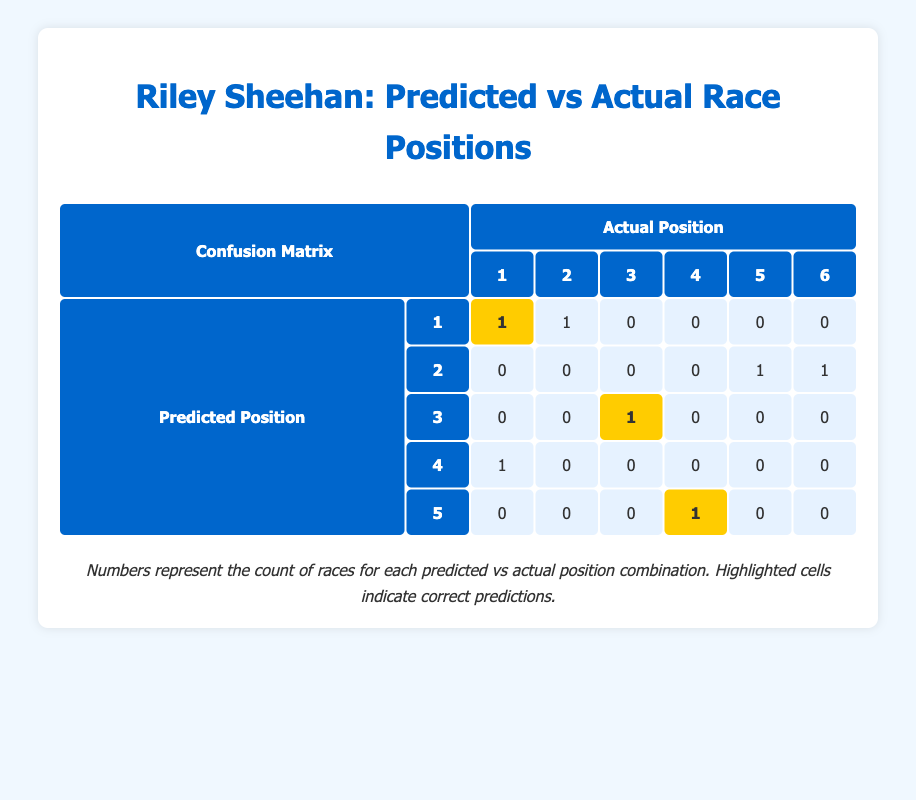What is the number of races where Riley Sheehan's predicted finishing position was correct? The highlighted cells in the table represent the correct predictions. There are three highlighted cells: the predicted position of 1 with an actual position of 1 for the Critérium du Dauphiné, the predicted position of 3 with an actual position of 3 for the Tour of California, and the predicted position of 5 with an actual position of 5 (which appears as 1 under the column of actual position 5). Therefore, the number of correct predictions is 3.
Answer: 3 How many times did Riley Sheehan finish in a higher position than predicted? To determine this, we look for entries where the actual position is lower than the predicted position. From the table, this occurs in one case: Gateway Cup with a predicted position of 4 and an actual position of 1. So, he finished higher than predicted once.
Answer: 1 What is the sum of all correct predictions made by Riley Sheehan? From the highlighted cells, there are three correct predictions (positions 1, 3, and 5) in total. The sum of the finish positions is obtained by summing these correct positions: 1 (for Critérium du Dauphiné) + 3 (for Tour of California) + 5 (for the 1st actual position in the predicted 5) = 9.
Answer: 9 Did Riley Sheehan ever predict a finishing position of 4 and achieve it? Checking the table, there is one entry with a predicted finishing position of 4 and an actual position of 4, which occurs in the Joe Martin Stage Race. Therefore, he did achieve this predicted position.
Answer: Yes 